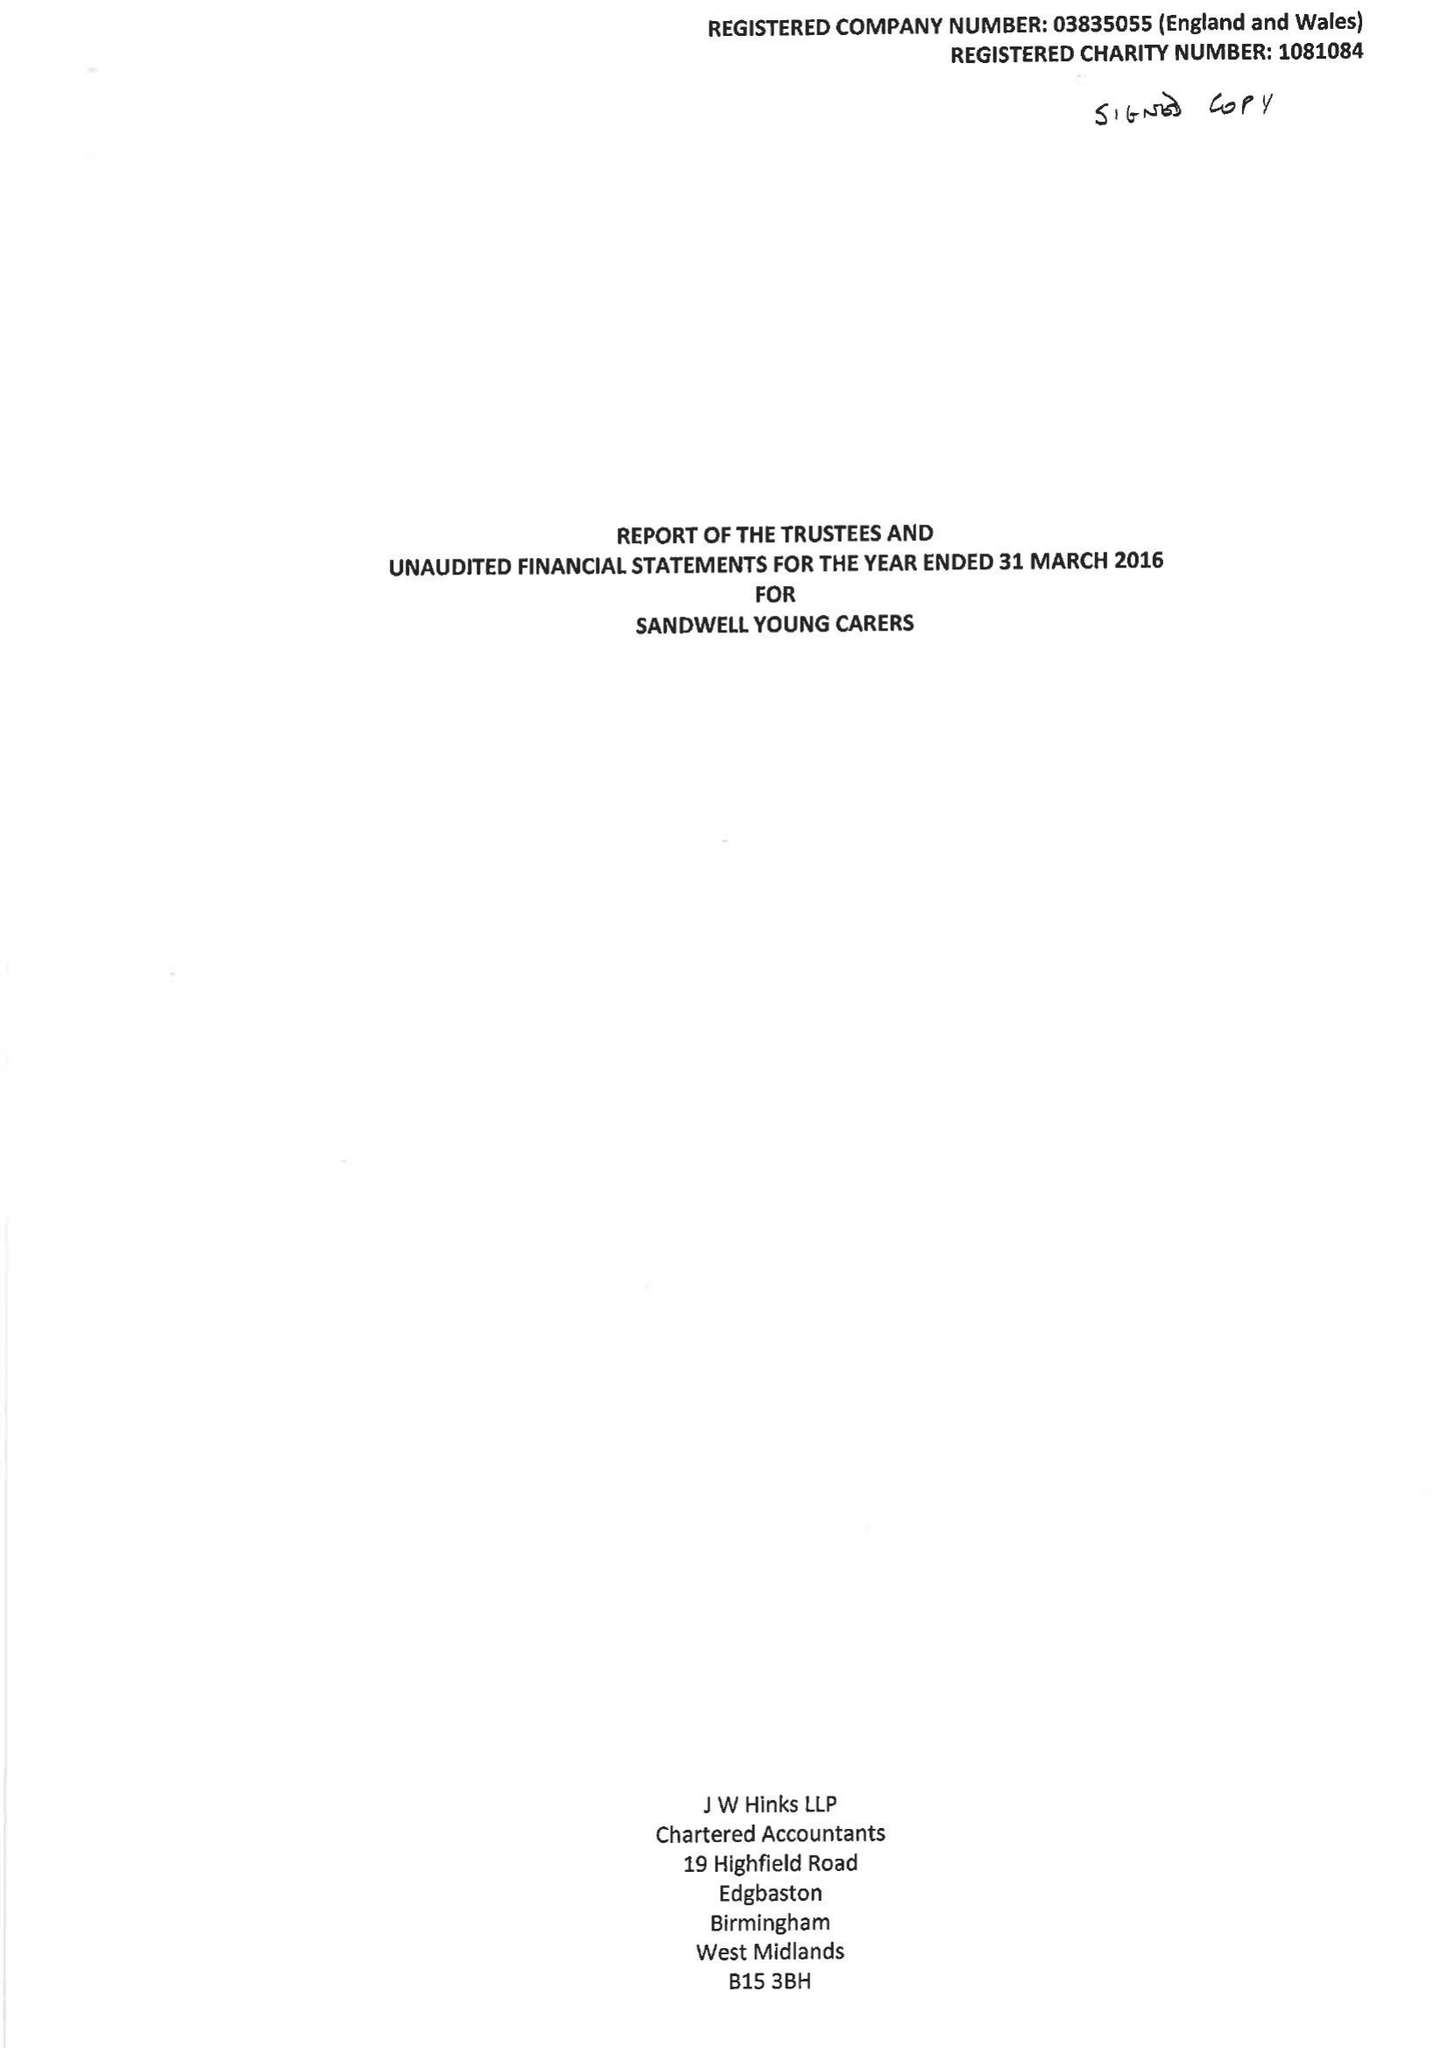What is the value for the charity_number?
Answer the question using a single word or phrase. 1081084 